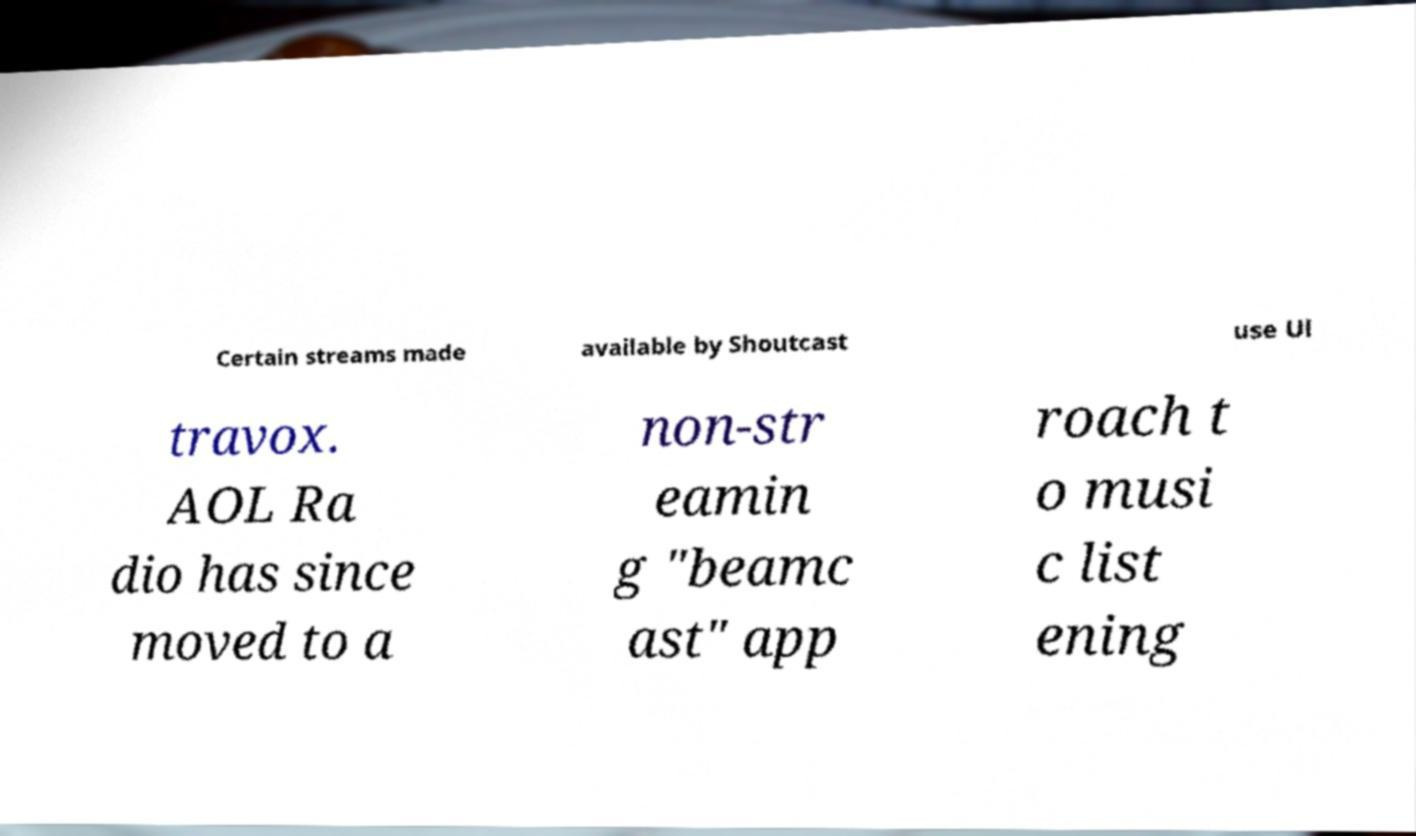I need the written content from this picture converted into text. Can you do that? Certain streams made available by Shoutcast use Ul travox. AOL Ra dio has since moved to a non-str eamin g "beamc ast" app roach t o musi c list ening 